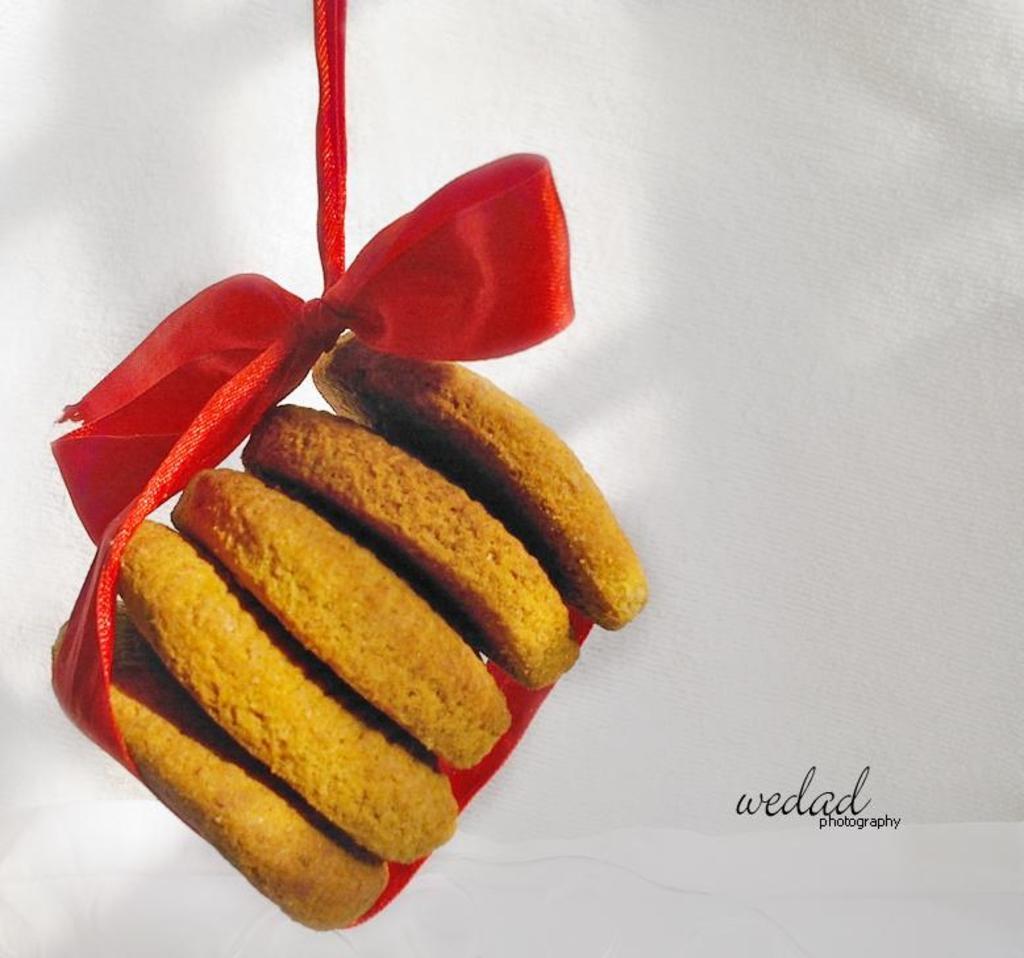Please provide a concise description of this image. In this image, we can see few cookies are tied with red ribbon. Background there is a white color. On the right side, we can see a watermark in the image. 